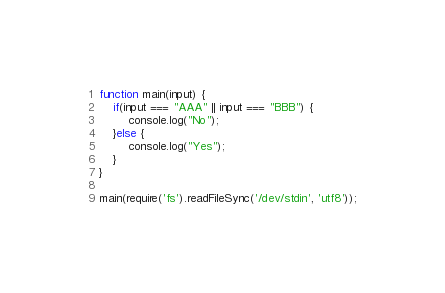<code> <loc_0><loc_0><loc_500><loc_500><_JavaScript_>function main(input) {
    if(input === "AAA" || input === "BBB") {
        console.log("No");
    }else {
        console.log("Yes");
    }
}

main(require('fs').readFileSync('/dev/stdin', 'utf8'));</code> 